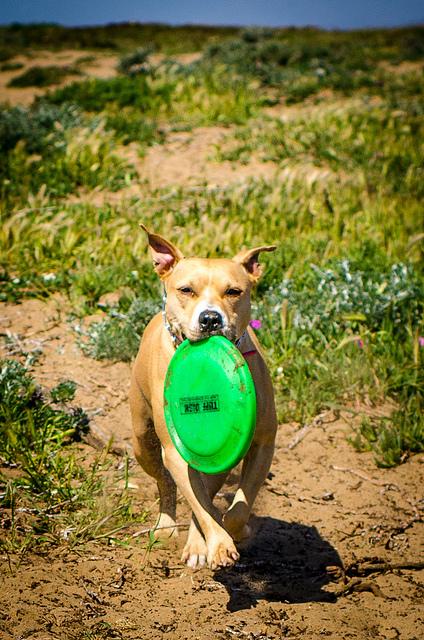Is the dog running?
Keep it brief. Yes. Is the dog holding a frisbee?
Short answer required. Yes. Is the dog black?
Answer briefly. No. 